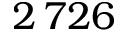Convert formula to latex. <formula><loc_0><loc_0><loc_500><loc_500>2 \, 7 2 6</formula> 